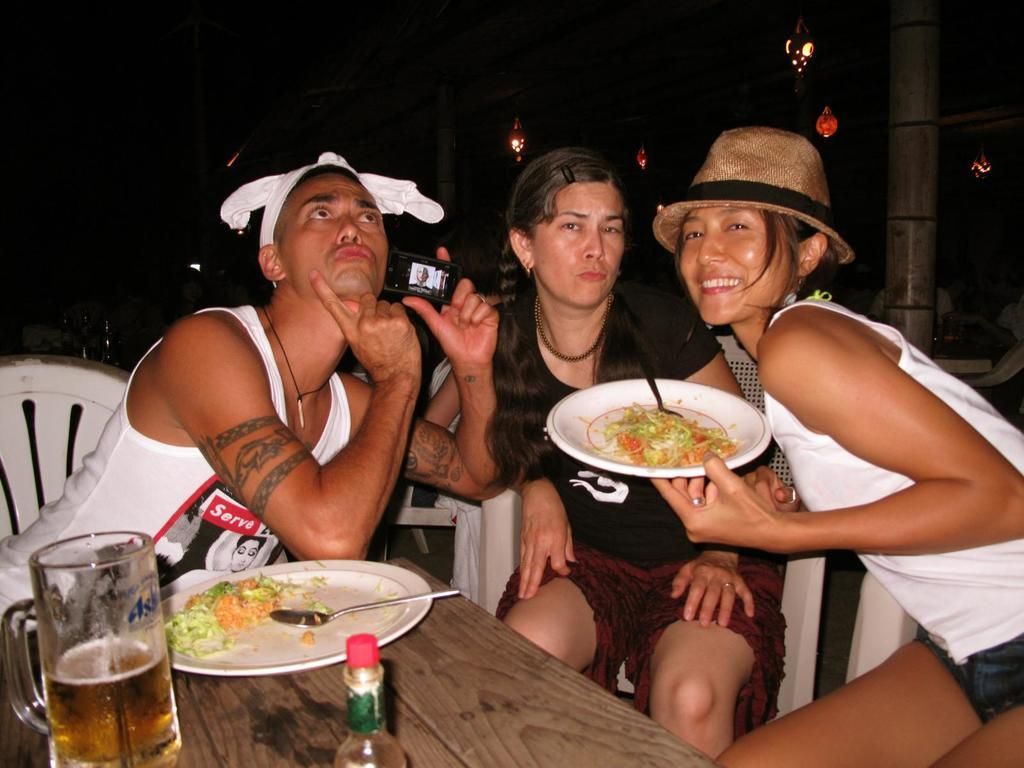How many people are sitting in the scene? There are three people sitting in the scene. What is the person on the right holding? The person on the right is holding a plate. What piece of furniture is present in the scene? There is a table in the scene. What items can be found on the table? There is a plate, a spoon, a glass, and a bottle on the table. What type of clover is growing on the table in the image? There is no clover present on the table in the image. What role does the dad play in the scene? There is no mention of a dad or any familial relationships in the image. 